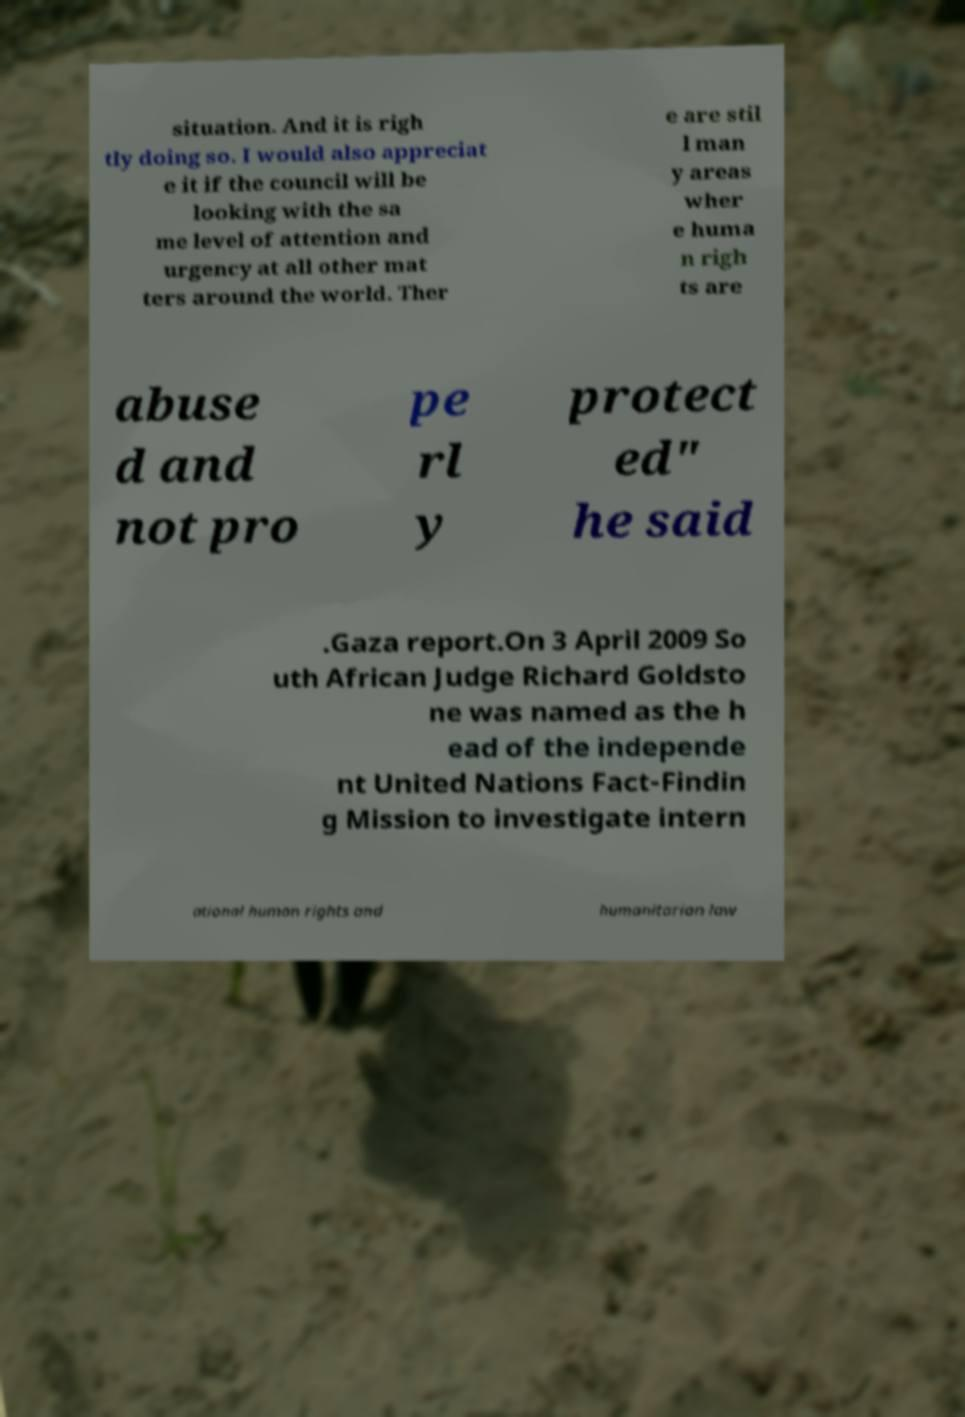What messages or text are displayed in this image? I need them in a readable, typed format. situation. And it is righ tly doing so. I would also appreciat e it if the council will be looking with the sa me level of attention and urgency at all other mat ters around the world. Ther e are stil l man y areas wher e huma n righ ts are abuse d and not pro pe rl y protect ed" he said .Gaza report.On 3 April 2009 So uth African Judge Richard Goldsto ne was named as the h ead of the independe nt United Nations Fact-Findin g Mission to investigate intern ational human rights and humanitarian law 